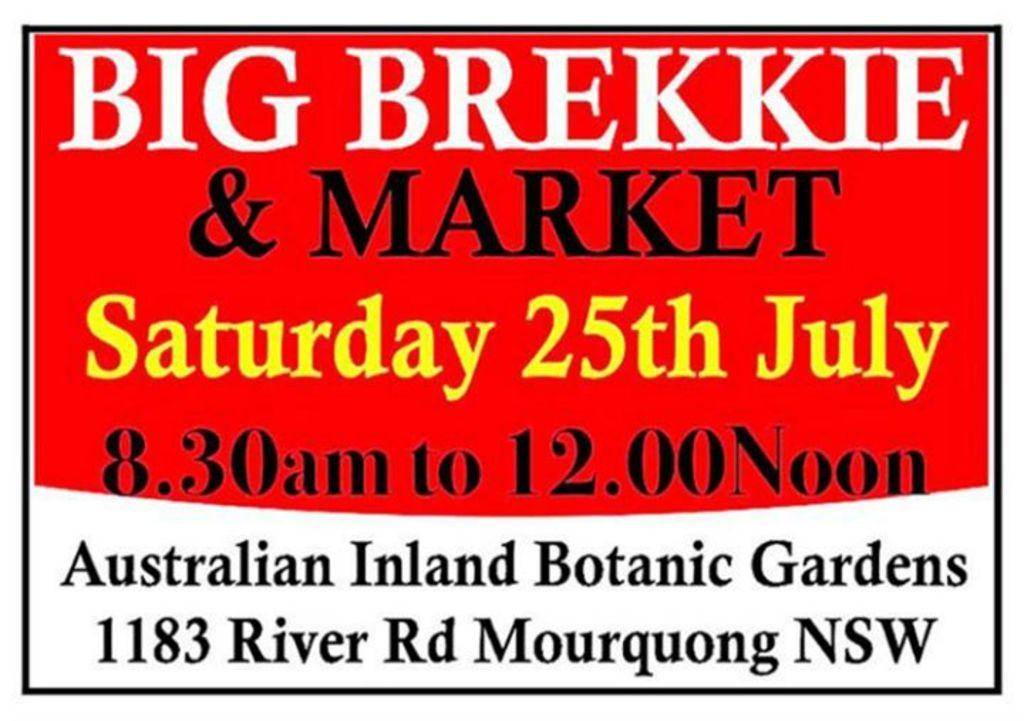<image>
Share a concise interpretation of the image provided. A red and wite sign that reads Big brekkie and market on the top. 